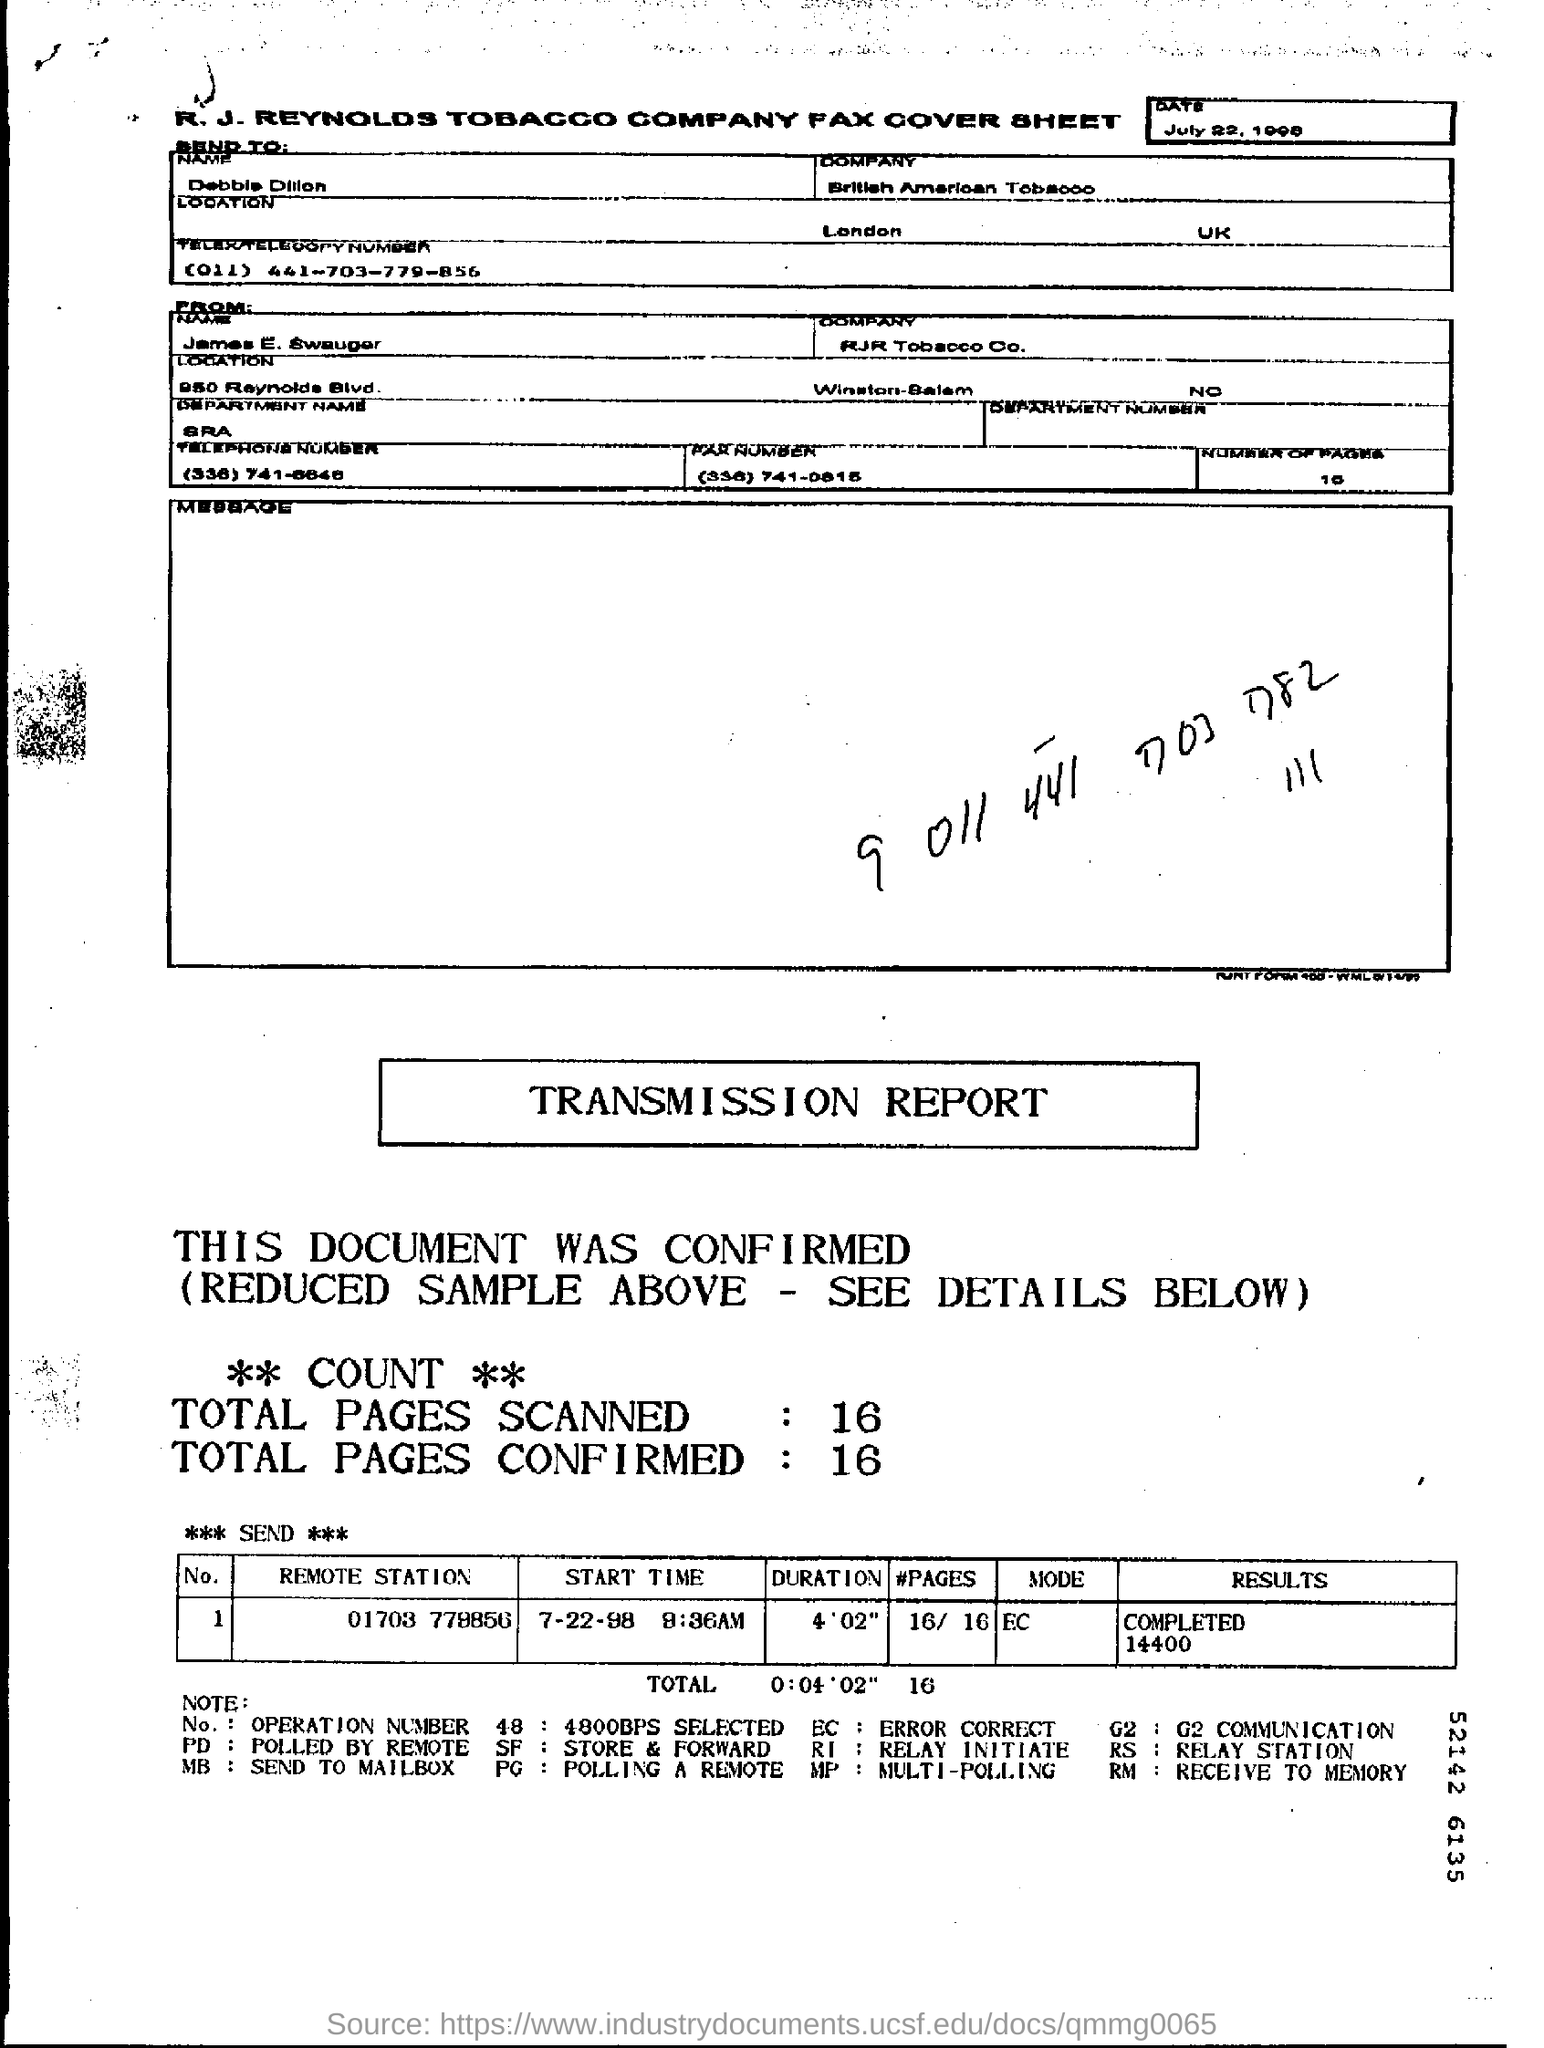WHAT IS THE SENDER COMAPANY NAME?
Make the answer very short. RJR Tobacco Co. WHO IS THE SENDER?
Your response must be concise. JAMES E. SWAUGER. WHAT IS THE NUMBER OF PAGES?
Offer a terse response. 10. WHAT IS THE REMOTE STATION NUMBER?
Provide a short and direct response. 01703 778856. 